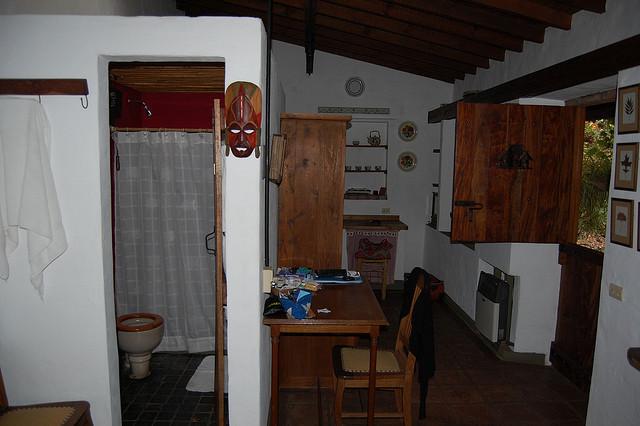How many chairs?
Give a very brief answer. 1. How many chairs are there?
Give a very brief answer. 1. 